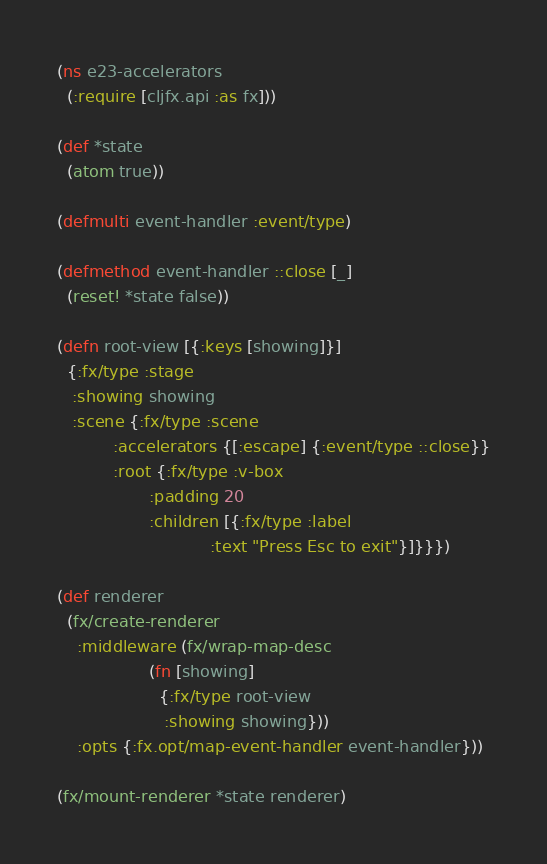<code> <loc_0><loc_0><loc_500><loc_500><_Clojure_>(ns e23-accelerators
  (:require [cljfx.api :as fx]))

(def *state
  (atom true))

(defmulti event-handler :event/type)

(defmethod event-handler ::close [_]
  (reset! *state false))

(defn root-view [{:keys [showing]}]
  {:fx/type :stage
   :showing showing
   :scene {:fx/type :scene
           :accelerators {[:escape] {:event/type ::close}}
           :root {:fx/type :v-box
                  :padding 20
                  :children [{:fx/type :label
                              :text "Press Esc to exit"}]}}})

(def renderer
  (fx/create-renderer
    :middleware (fx/wrap-map-desc
                  (fn [showing]
                    {:fx/type root-view
                     :showing showing}))
    :opts {:fx.opt/map-event-handler event-handler}))

(fx/mount-renderer *state renderer)
</code> 